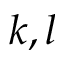Convert formula to latex. <formula><loc_0><loc_0><loc_500><loc_500>k , l</formula> 